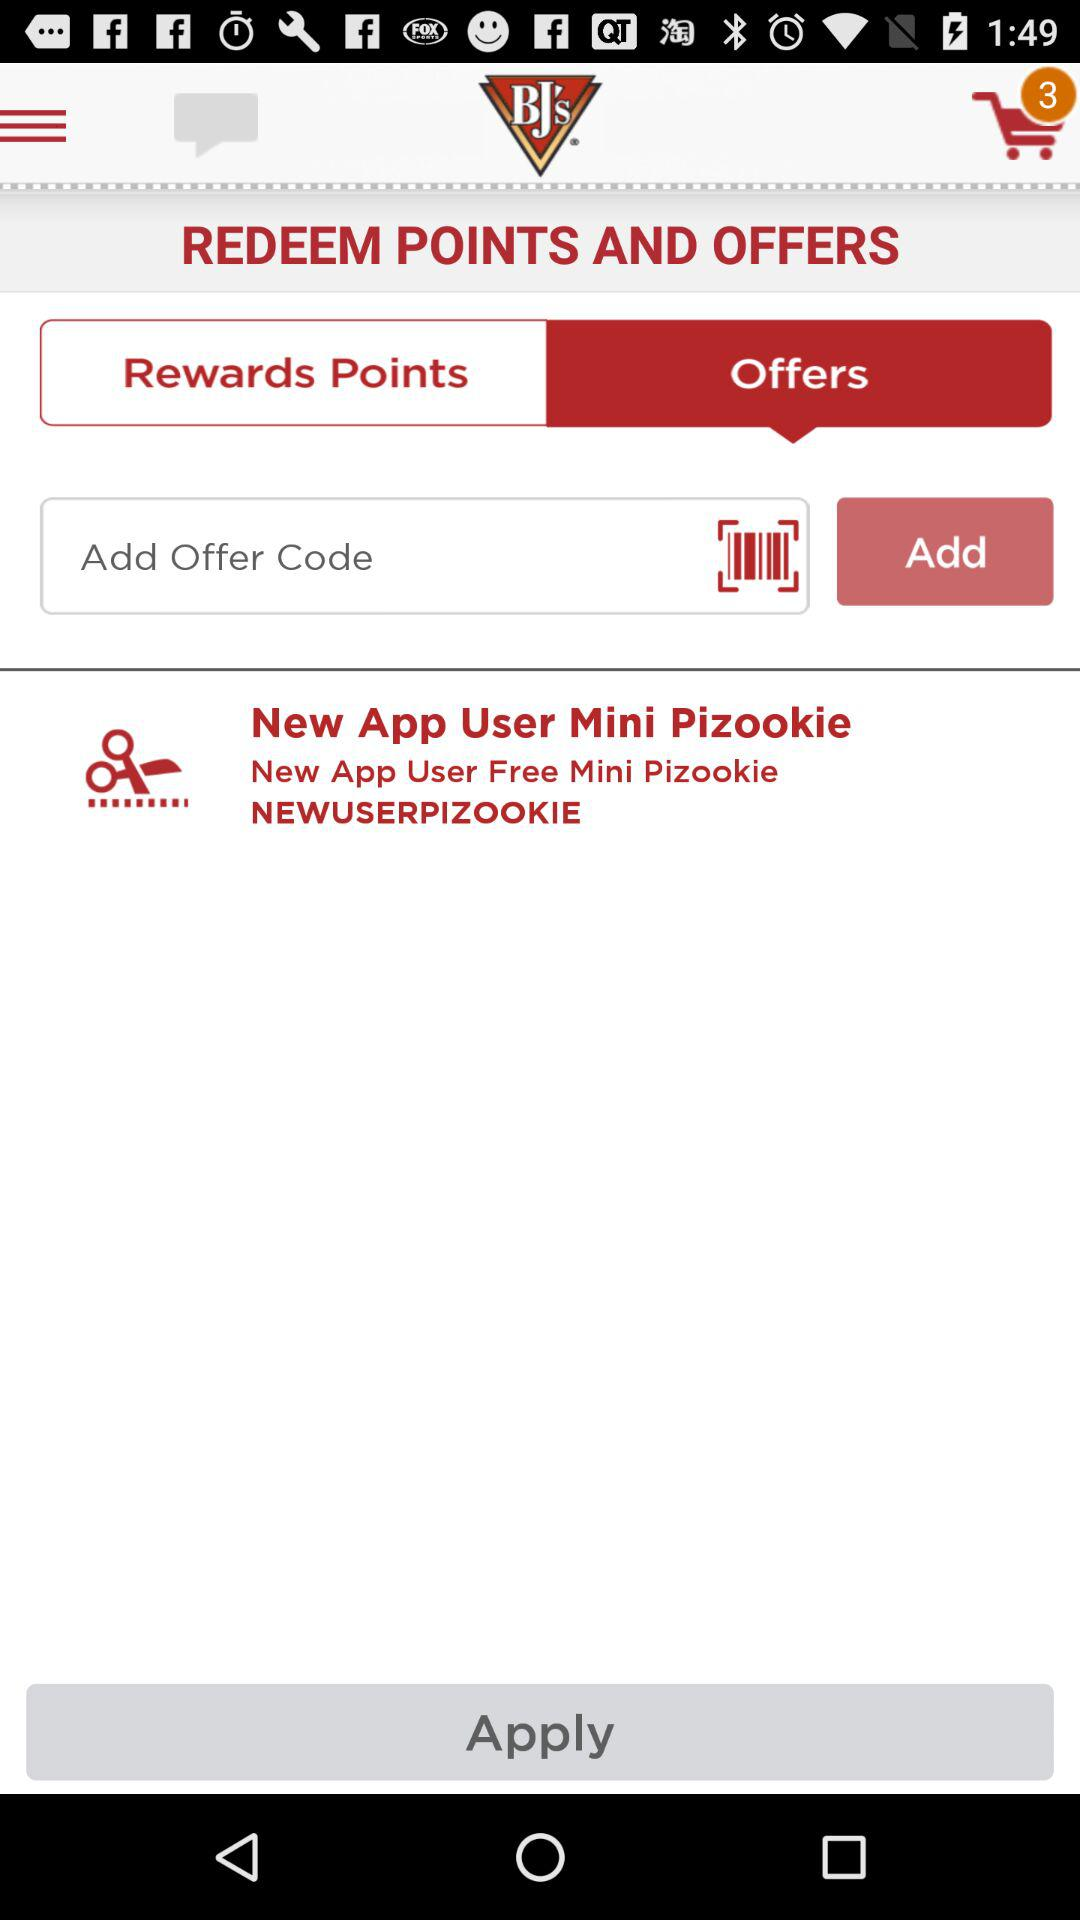What is the offer code? The offer code is NEWUSERPIZOOKIE. 